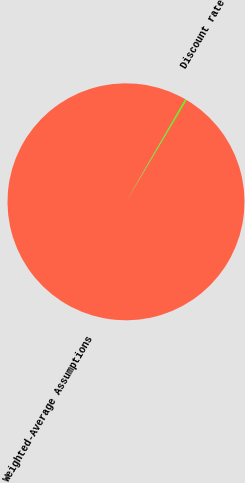<chart> <loc_0><loc_0><loc_500><loc_500><pie_chart><fcel>Weighted-Average Assumptions<fcel>Discount rate<nl><fcel>99.82%<fcel>0.18%<nl></chart> 